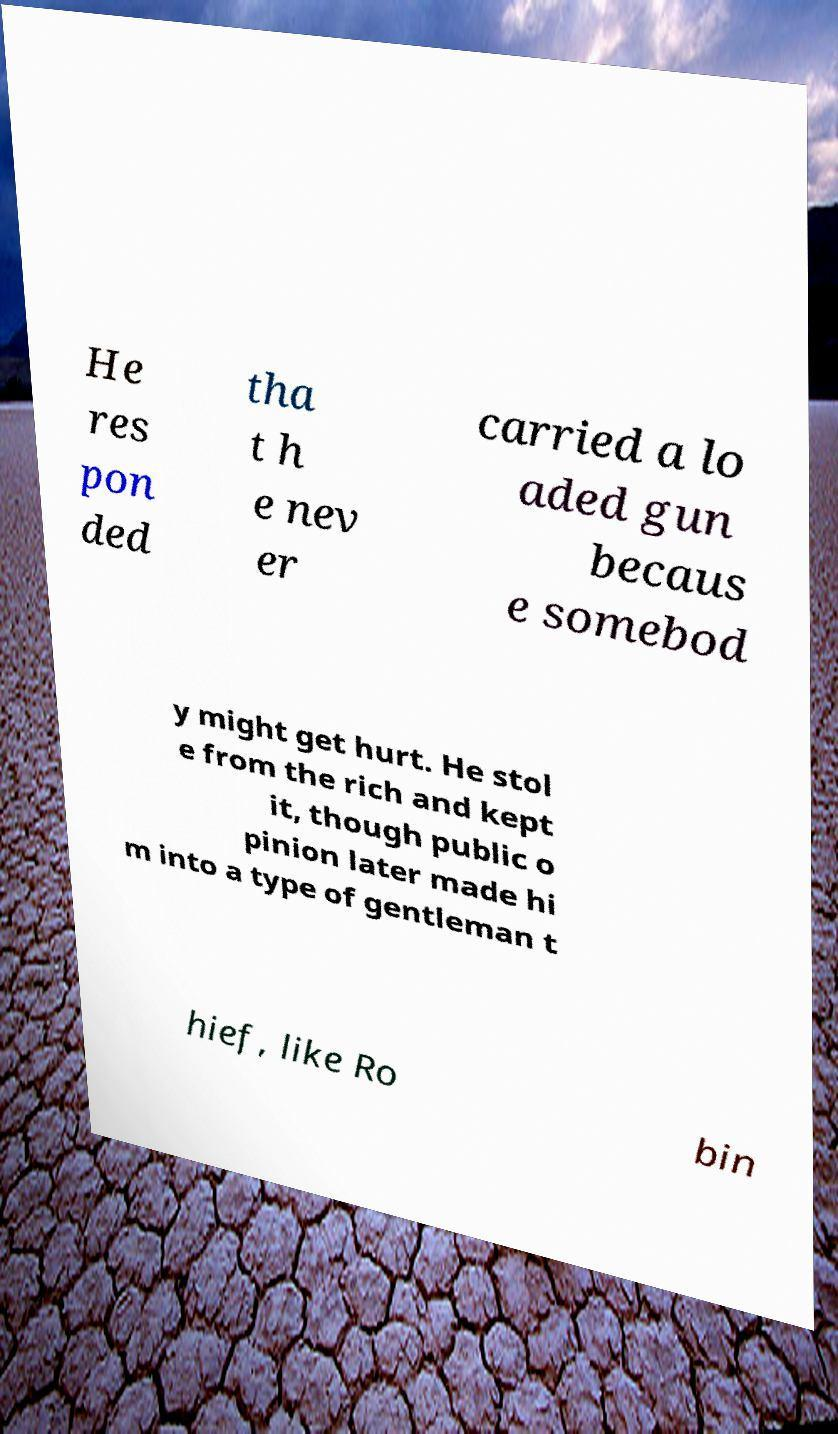There's text embedded in this image that I need extracted. Can you transcribe it verbatim? He res pon ded tha t h e nev er carried a lo aded gun becaus e somebod y might get hurt. He stol e from the rich and kept it, though public o pinion later made hi m into a type of gentleman t hief, like Ro bin 